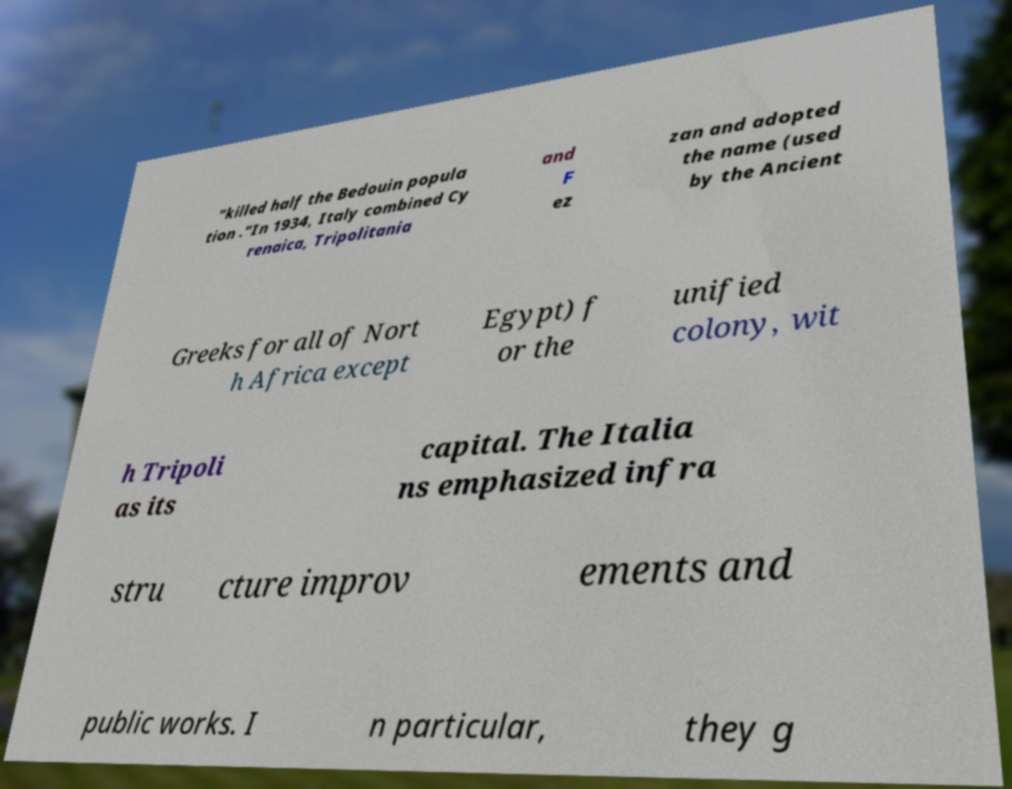Please identify and transcribe the text found in this image. "killed half the Bedouin popula tion ."In 1934, Italy combined Cy renaica, Tripolitania and F ez zan and adopted the name (used by the Ancient Greeks for all of Nort h Africa except Egypt) f or the unified colony, wit h Tripoli as its capital. The Italia ns emphasized infra stru cture improv ements and public works. I n particular, they g 